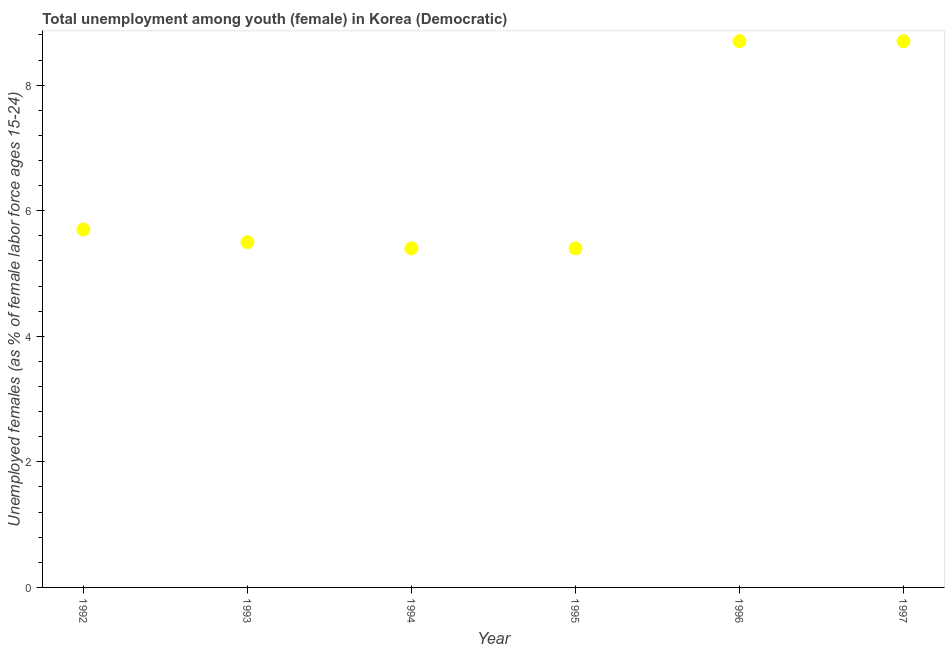What is the unemployed female youth population in 1995?
Provide a succinct answer. 5.4. Across all years, what is the maximum unemployed female youth population?
Your answer should be compact. 8.7. Across all years, what is the minimum unemployed female youth population?
Your answer should be very brief. 5.4. In which year was the unemployed female youth population maximum?
Give a very brief answer. 1996. What is the sum of the unemployed female youth population?
Offer a terse response. 39.4. What is the difference between the unemployed female youth population in 1994 and 1996?
Give a very brief answer. -3.3. What is the average unemployed female youth population per year?
Offer a very short reply. 6.57. What is the median unemployed female youth population?
Ensure brevity in your answer.  5.6. Do a majority of the years between 1997 and 1993 (inclusive) have unemployed female youth population greater than 1.6 %?
Keep it short and to the point. Yes. What is the ratio of the unemployed female youth population in 1993 to that in 1996?
Keep it short and to the point. 0.63. Is the unemployed female youth population in 1992 less than that in 1995?
Provide a short and direct response. No. Is the difference between the unemployed female youth population in 1994 and 1995 greater than the difference between any two years?
Your response must be concise. No. What is the difference between the highest and the second highest unemployed female youth population?
Your answer should be very brief. 0. Is the sum of the unemployed female youth population in 1992 and 1995 greater than the maximum unemployed female youth population across all years?
Provide a succinct answer. Yes. What is the difference between the highest and the lowest unemployed female youth population?
Provide a succinct answer. 3.3. How many dotlines are there?
Your response must be concise. 1. How many years are there in the graph?
Ensure brevity in your answer.  6. What is the difference between two consecutive major ticks on the Y-axis?
Your response must be concise. 2. Does the graph contain grids?
Ensure brevity in your answer.  No. What is the title of the graph?
Keep it short and to the point. Total unemployment among youth (female) in Korea (Democratic). What is the label or title of the X-axis?
Give a very brief answer. Year. What is the label or title of the Y-axis?
Offer a terse response. Unemployed females (as % of female labor force ages 15-24). What is the Unemployed females (as % of female labor force ages 15-24) in 1992?
Offer a terse response. 5.7. What is the Unemployed females (as % of female labor force ages 15-24) in 1993?
Give a very brief answer. 5.5. What is the Unemployed females (as % of female labor force ages 15-24) in 1994?
Provide a succinct answer. 5.4. What is the Unemployed females (as % of female labor force ages 15-24) in 1995?
Keep it short and to the point. 5.4. What is the Unemployed females (as % of female labor force ages 15-24) in 1996?
Give a very brief answer. 8.7. What is the Unemployed females (as % of female labor force ages 15-24) in 1997?
Your answer should be compact. 8.7. What is the difference between the Unemployed females (as % of female labor force ages 15-24) in 1993 and 1996?
Your answer should be compact. -3.2. What is the difference between the Unemployed females (as % of female labor force ages 15-24) in 1993 and 1997?
Keep it short and to the point. -3.2. What is the difference between the Unemployed females (as % of female labor force ages 15-24) in 1994 and 1995?
Offer a very short reply. 0. What is the difference between the Unemployed females (as % of female labor force ages 15-24) in 1994 and 1997?
Provide a succinct answer. -3.3. What is the difference between the Unemployed females (as % of female labor force ages 15-24) in 1995 and 1997?
Offer a terse response. -3.3. What is the difference between the Unemployed females (as % of female labor force ages 15-24) in 1996 and 1997?
Your answer should be very brief. 0. What is the ratio of the Unemployed females (as % of female labor force ages 15-24) in 1992 to that in 1993?
Keep it short and to the point. 1.04. What is the ratio of the Unemployed females (as % of female labor force ages 15-24) in 1992 to that in 1994?
Provide a short and direct response. 1.06. What is the ratio of the Unemployed females (as % of female labor force ages 15-24) in 1992 to that in 1995?
Offer a terse response. 1.06. What is the ratio of the Unemployed females (as % of female labor force ages 15-24) in 1992 to that in 1996?
Your answer should be compact. 0.66. What is the ratio of the Unemployed females (as % of female labor force ages 15-24) in 1992 to that in 1997?
Offer a very short reply. 0.66. What is the ratio of the Unemployed females (as % of female labor force ages 15-24) in 1993 to that in 1996?
Ensure brevity in your answer.  0.63. What is the ratio of the Unemployed females (as % of female labor force ages 15-24) in 1993 to that in 1997?
Provide a succinct answer. 0.63. What is the ratio of the Unemployed females (as % of female labor force ages 15-24) in 1994 to that in 1995?
Provide a short and direct response. 1. What is the ratio of the Unemployed females (as % of female labor force ages 15-24) in 1994 to that in 1996?
Give a very brief answer. 0.62. What is the ratio of the Unemployed females (as % of female labor force ages 15-24) in 1994 to that in 1997?
Ensure brevity in your answer.  0.62. What is the ratio of the Unemployed females (as % of female labor force ages 15-24) in 1995 to that in 1996?
Make the answer very short. 0.62. What is the ratio of the Unemployed females (as % of female labor force ages 15-24) in 1995 to that in 1997?
Ensure brevity in your answer.  0.62. 